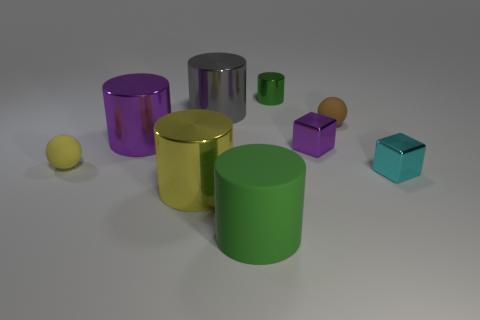Subtract all big yellow cylinders. How many cylinders are left? 4 Subtract all cyan blocks. How many blocks are left? 1 Subtract all blue balls. How many green cylinders are left? 2 Subtract 1 cubes. How many cubes are left? 1 Subtract all spheres. How many objects are left? 7 Add 9 large purple metal things. How many large purple metal things exist? 10 Subtract 0 blue blocks. How many objects are left? 9 Subtract all brown cylinders. Subtract all red blocks. How many cylinders are left? 5 Subtract all large yellow things. Subtract all purple shiny cubes. How many objects are left? 7 Add 6 big purple cylinders. How many big purple cylinders are left? 7 